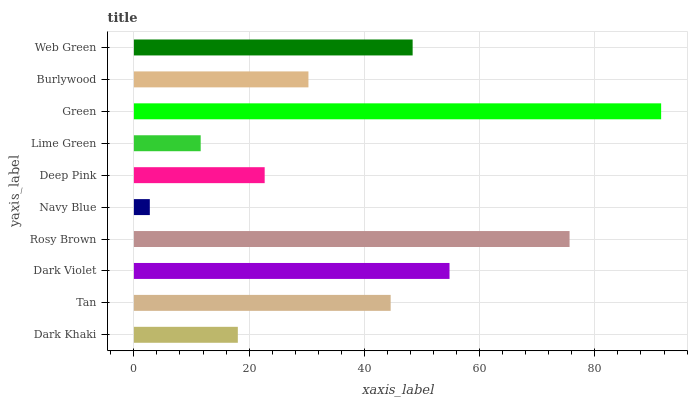Is Navy Blue the minimum?
Answer yes or no. Yes. Is Green the maximum?
Answer yes or no. Yes. Is Tan the minimum?
Answer yes or no. No. Is Tan the maximum?
Answer yes or no. No. Is Tan greater than Dark Khaki?
Answer yes or no. Yes. Is Dark Khaki less than Tan?
Answer yes or no. Yes. Is Dark Khaki greater than Tan?
Answer yes or no. No. Is Tan less than Dark Khaki?
Answer yes or no. No. Is Tan the high median?
Answer yes or no. Yes. Is Burlywood the low median?
Answer yes or no. Yes. Is Burlywood the high median?
Answer yes or no. No. Is Dark Khaki the low median?
Answer yes or no. No. 